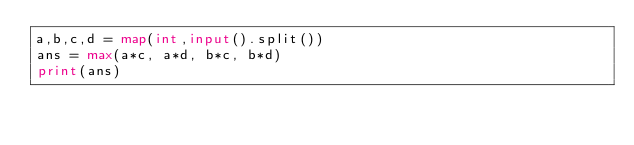<code> <loc_0><loc_0><loc_500><loc_500><_Python_>a,b,c,d = map(int,input().split())
ans = max(a*c, a*d, b*c, b*d)
print(ans)
</code> 